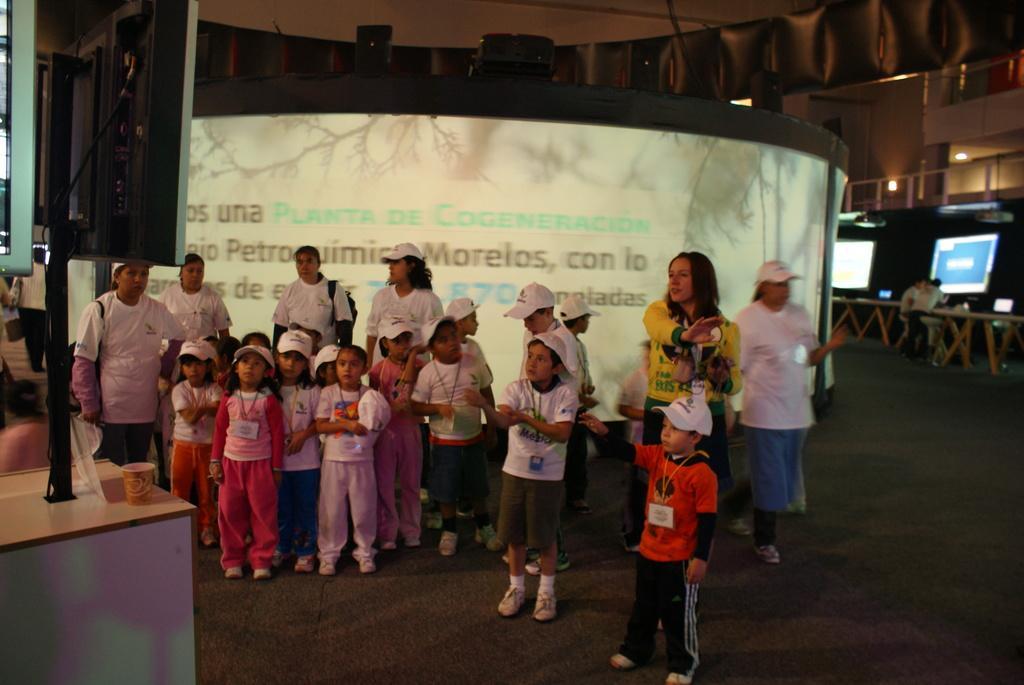In one or two sentences, can you explain what this image depicts? In this image there are group of people with hats are standing , and in the background there are screens, tables, lights. 